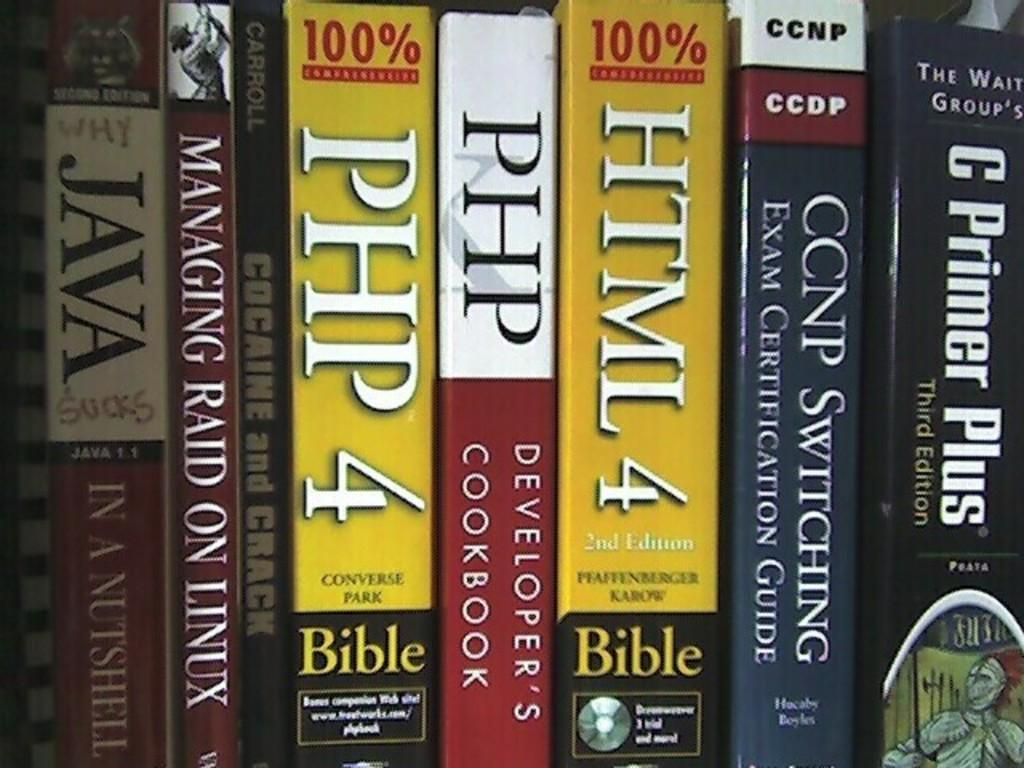<image>
Share a concise interpretation of the image provided. Several books, including two copies of PHP 4 Bible, are lined up on a shelf. 